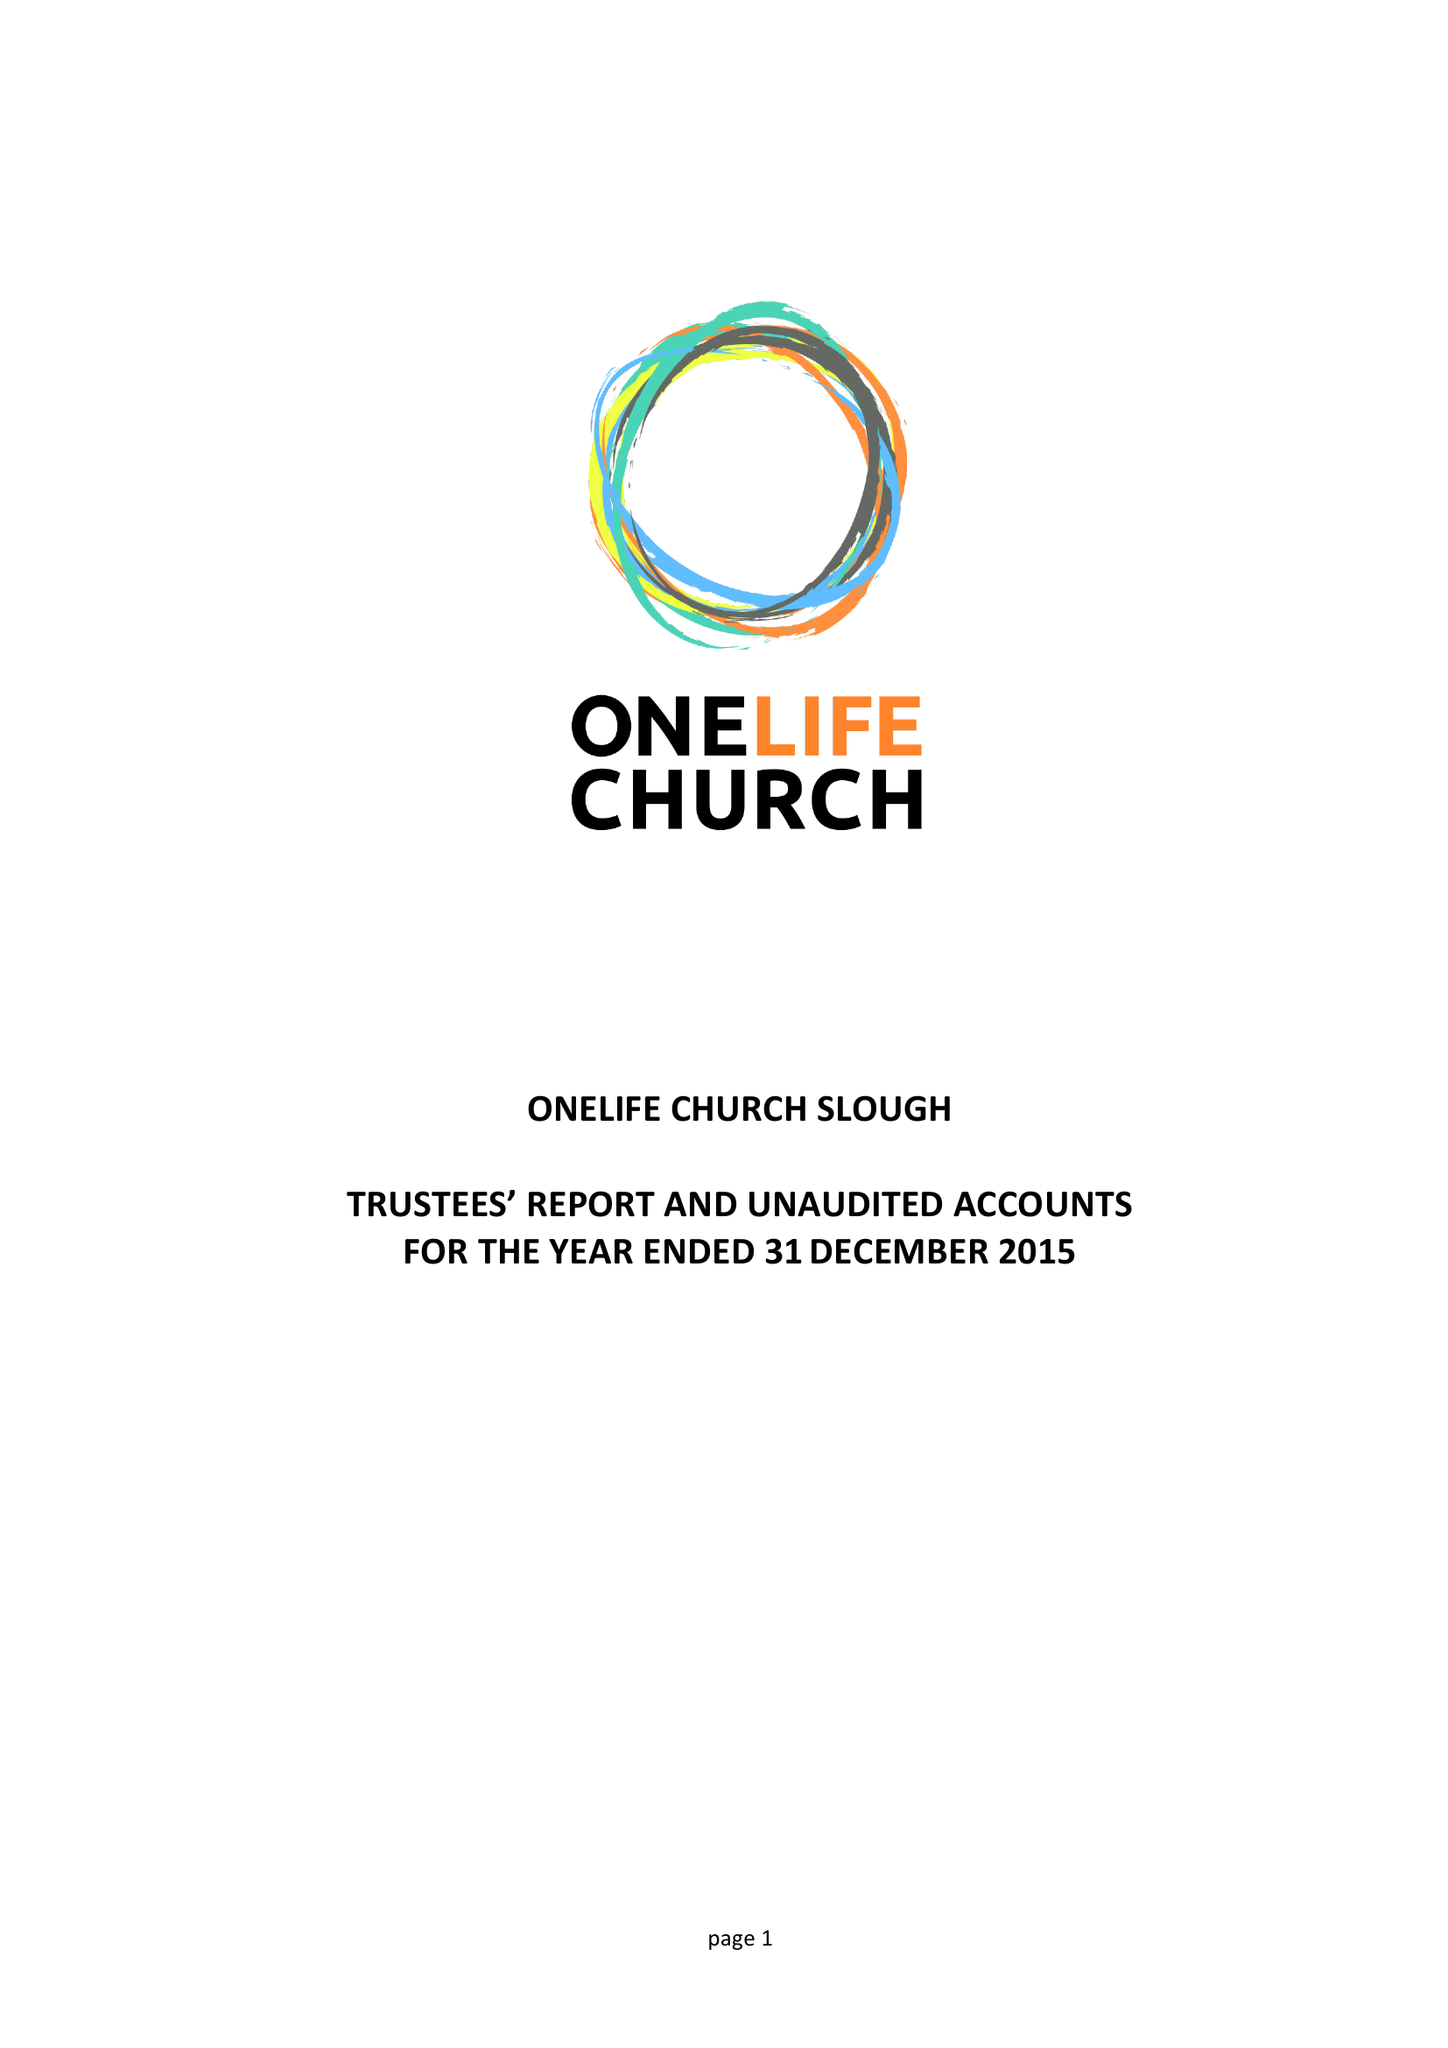What is the value for the report_date?
Answer the question using a single word or phrase. 2015-12-31 